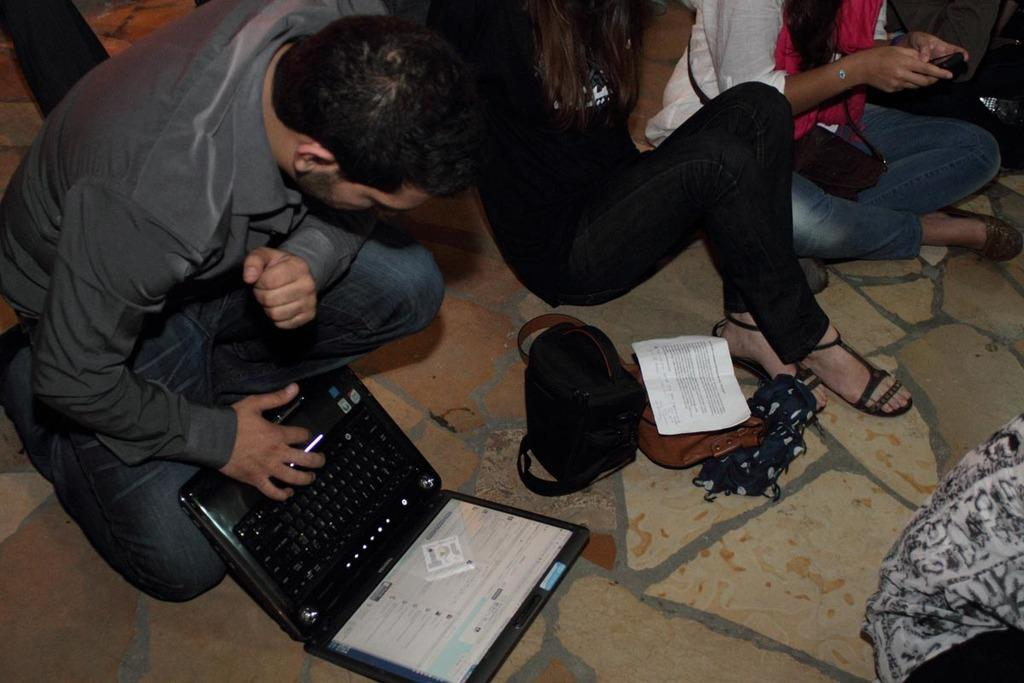What are the people in the image doing? The people in the image are sitting on the floor. What else can be seen on the floor in the image? There are objects on the floor in the image. Can you identify any electronic devices in the image? Yes, there is an electronic gadget visible in the image. How does the stranger play with the people sitting on the floor in the image? There is no stranger present in the image, so this question cannot be answered. 